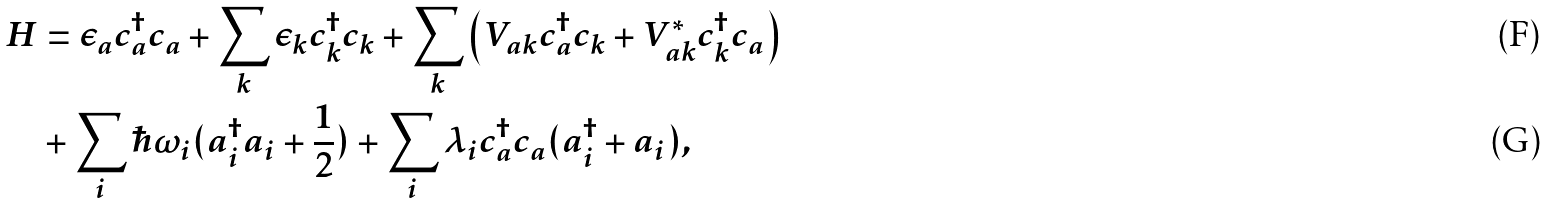<formula> <loc_0><loc_0><loc_500><loc_500>H & = \epsilon _ { a } c _ { a } ^ { \dag } c _ { a } + \sum _ { k } \epsilon _ { k } c _ { k } ^ { \dag } c _ { k } + \sum _ { k } \left ( V _ { a k } c _ { a } ^ { \dag } c _ { k } + V _ { a k } ^ { * } c _ { k } ^ { \dag } c _ { a } \right ) \\ & + \sum _ { i } \hbar { \omega } _ { i } ( a _ { i } ^ { \dag } a _ { i } + \frac { 1 } { 2 } ) + \sum _ { i } \lambda _ { i } c _ { a } ^ { \dag } c _ { a } ( a _ { i } ^ { \dag } + a _ { i } ) ,</formula> 